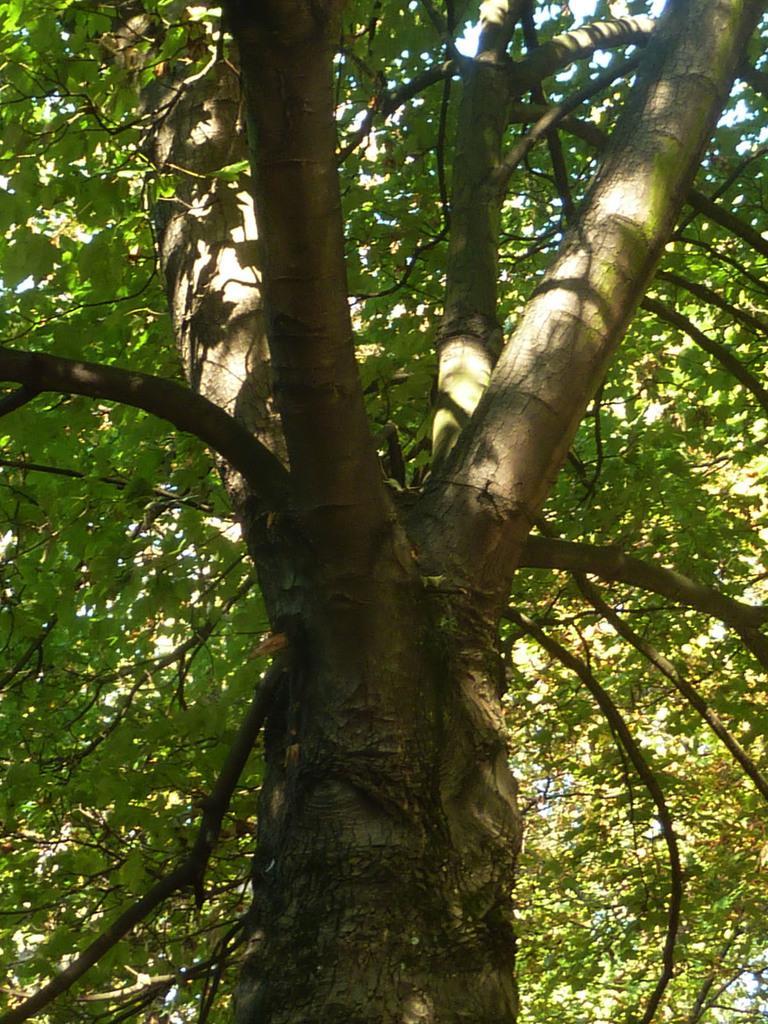In one or two sentences, can you explain what this image depicts? We can see trees and in the background there is a sky. 